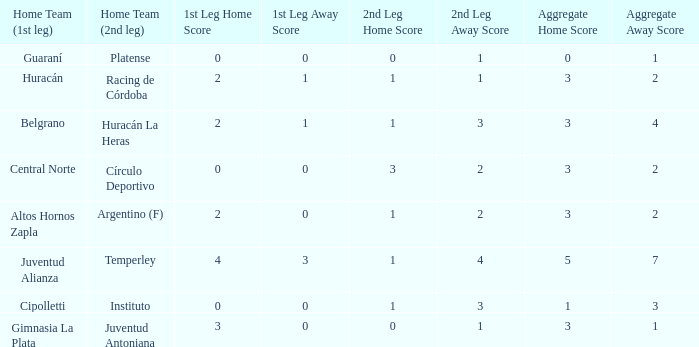Give me the full table as a dictionary. {'header': ['Home Team (1st leg)', 'Home Team (2nd leg)', '1st Leg Home Score', '1st Leg Away Score', '2nd Leg Home Score', '2nd Leg Away Score', 'Aggregate Home Score', 'Aggregate Away Score'], 'rows': [['Guaraní', 'Platense', '0', '0', '0', '1', '0', '1'], ['Huracán', 'Racing de Córdoba', '2', '1', '1', '1', '3', '2'], ['Belgrano', 'Huracán La Heras', '2', '1', '1', '3', '3', '4'], ['Central Norte', 'Círculo Deportivo', '0', '0', '3', '2', '3', '2'], ['Altos Hornos Zapla', 'Argentino (F)', '2', '0', '1', '2', '3', '2'], ['Juventud Alianza', 'Temperley', '4', '3', '1', '4', '5', '7'], ['Cipolletti', 'Instituto', '0', '0', '1', '3', '1', '3'], ['Gimnasia La Plata', 'Juventud Antoniana', '3', '0', '0', '1', '3', '1']]} Which team played the 2nd leg at home with a tie of 1-1 and scored 3-2 in aggregate? Racing de Córdoba. 